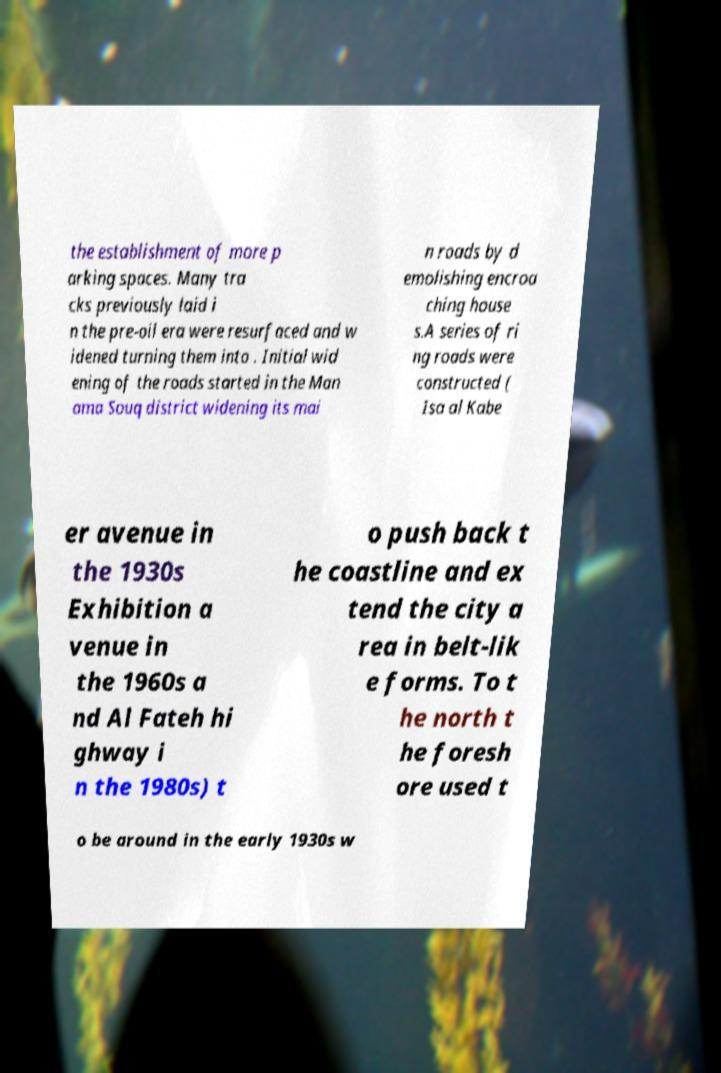Can you read and provide the text displayed in the image?This photo seems to have some interesting text. Can you extract and type it out for me? the establishment of more p arking spaces. Many tra cks previously laid i n the pre-oil era were resurfaced and w idened turning them into . Initial wid ening of the roads started in the Man ama Souq district widening its mai n roads by d emolishing encroa ching house s.A series of ri ng roads were constructed ( Isa al Kabe er avenue in the 1930s Exhibition a venue in the 1960s a nd Al Fateh hi ghway i n the 1980s) t o push back t he coastline and ex tend the city a rea in belt-lik e forms. To t he north t he foresh ore used t o be around in the early 1930s w 